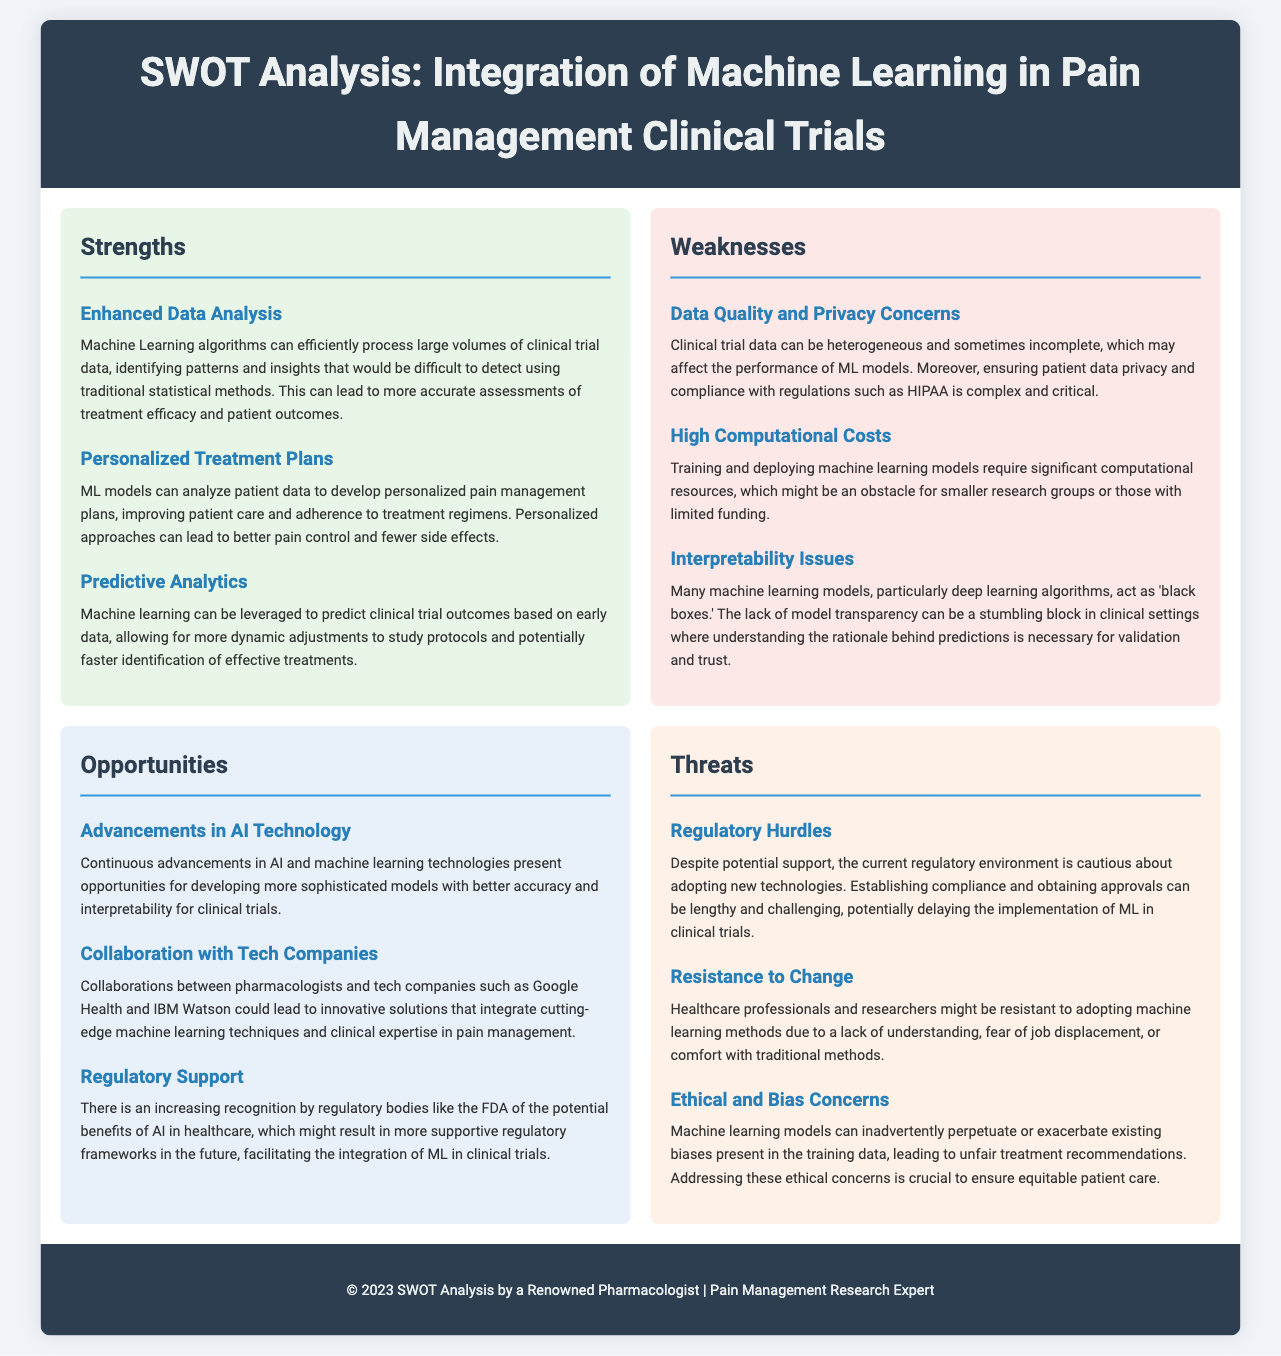What is the main focus of the SWOT analysis? The SWOT analysis focuses on the integration of machine learning in pain management clinical trials.
Answer: Integration of machine learning in pain management clinical trials How many strengths are listed in the document? There are three strengths presented in the SWOT analysis.
Answer: Three What is one weakness related to data in the document? One weakness is about data quality and privacy concerns.
Answer: Data quality and privacy concerns Which opportunity discusses partnerships with tech companies? The opportunity regarding collaboration with tech companies mentions potential partnerships.
Answer: Collaboration with tech companies What is a threat related to the adoption of new technologies? Regulatory hurdles are mentioned as a threat to the adoption of new technologies.
Answer: Regulatory hurdles Name one advantage of using machine learning according to the strengths section. Enhanced data analysis is one advantage highlighted in the strengths section.
Answer: Enhanced data analysis What is a concern mentioned about machine learning models? Ethical and bias concerns are one of the threats mentioned regarding machine learning models.
Answer: Ethical and bias concerns What is one reason given for resistance to change in the document? A lack of understanding is cited as one reason for resistance to change.
Answer: A lack of understanding 